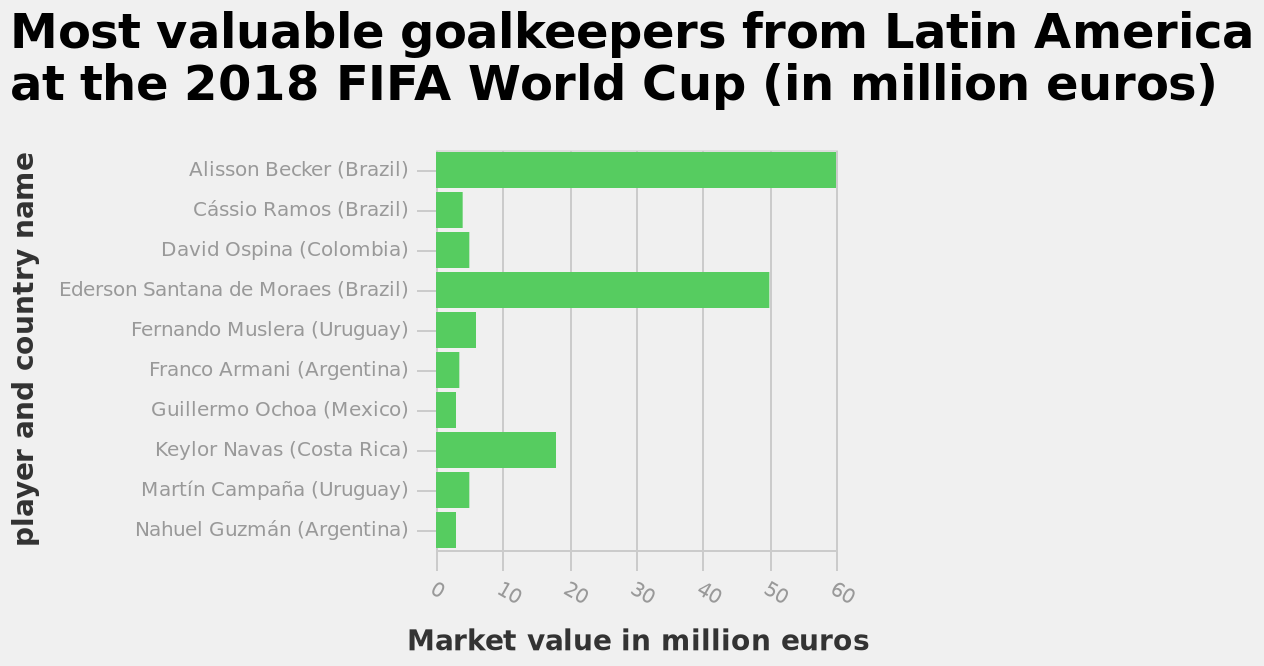<image>
What is the range of the linear scale on the x-axis? The linear scale on the x-axis ranges from 0 to 60. Offer a thorough analysis of the image. The most valuable player is Alisson Becker with market value at 60 million euros and the least valuable player are Nahuel Guzman and Guillermo Ochoa at around 2 million euros. Argentina has the most players with the lowest value and Brazil has the most players with the highest value. Does the linear scale on the x-axis range from 100 to 60? No.The linear scale on the x-axis ranges from 0 to 60. 